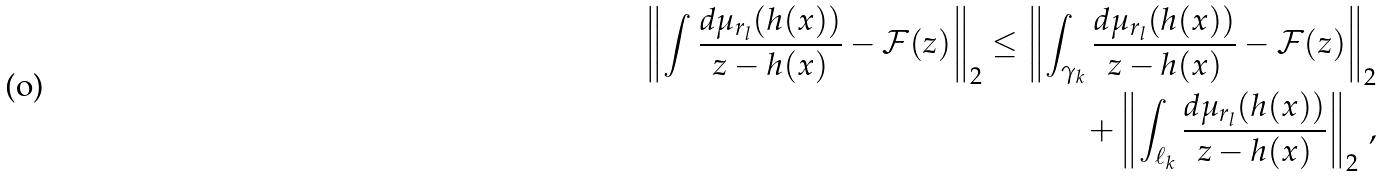<formula> <loc_0><loc_0><loc_500><loc_500>\left \| \int \frac { d \mu _ { r _ { l } } ( h ( x ) ) } { z - h ( x ) } - { \mathcal { F } } ( z ) \right \| _ { 2 } \leq \left \| \int _ { \gamma _ { k } } \frac { d \mu _ { r _ { l } } ( h ( x ) ) } { z - h ( x ) } - { \mathcal { F } } ( z ) \right \| _ { 2 } \\ + \left \| \int _ { \ell _ { k } } \frac { d \mu _ { r _ { l } } ( h ( x ) ) } { z - h ( x ) } \right \| _ { 2 } \, ,</formula> 